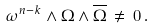<formula> <loc_0><loc_0><loc_500><loc_500>\omega ^ { n - k } \wedge \Omega \wedge \overline { \Omega } \, \ne \, 0 \, .</formula> 